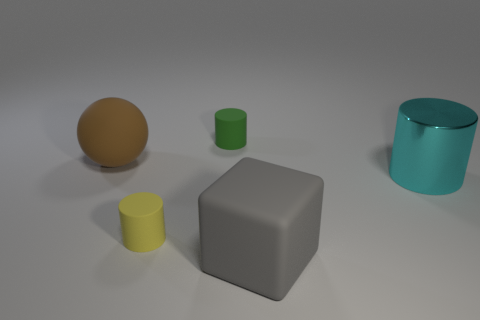What number of objects are either yellow rubber balls or spheres?
Offer a very short reply. 1. There is a brown sphere that is behind the tiny matte cylinder that is to the left of the small cylinder that is behind the big brown rubber ball; what is it made of?
Your answer should be very brief. Rubber. What is the small cylinder that is in front of the small green cylinder made of?
Provide a short and direct response. Rubber. Are there any yellow objects of the same size as the matte sphere?
Provide a short and direct response. No. There is a small matte cylinder in front of the brown matte ball; is its color the same as the large cylinder?
Provide a succinct answer. No. How many blue objects are big things or spheres?
Make the answer very short. 0. Does the big brown sphere have the same material as the small yellow thing?
Your answer should be very brief. Yes. There is a small rubber object in front of the large brown thing; how many yellow objects are behind it?
Make the answer very short. 0. Do the cyan cylinder and the brown rubber object have the same size?
Your response must be concise. Yes. What number of small brown things are made of the same material as the green object?
Provide a succinct answer. 0. 